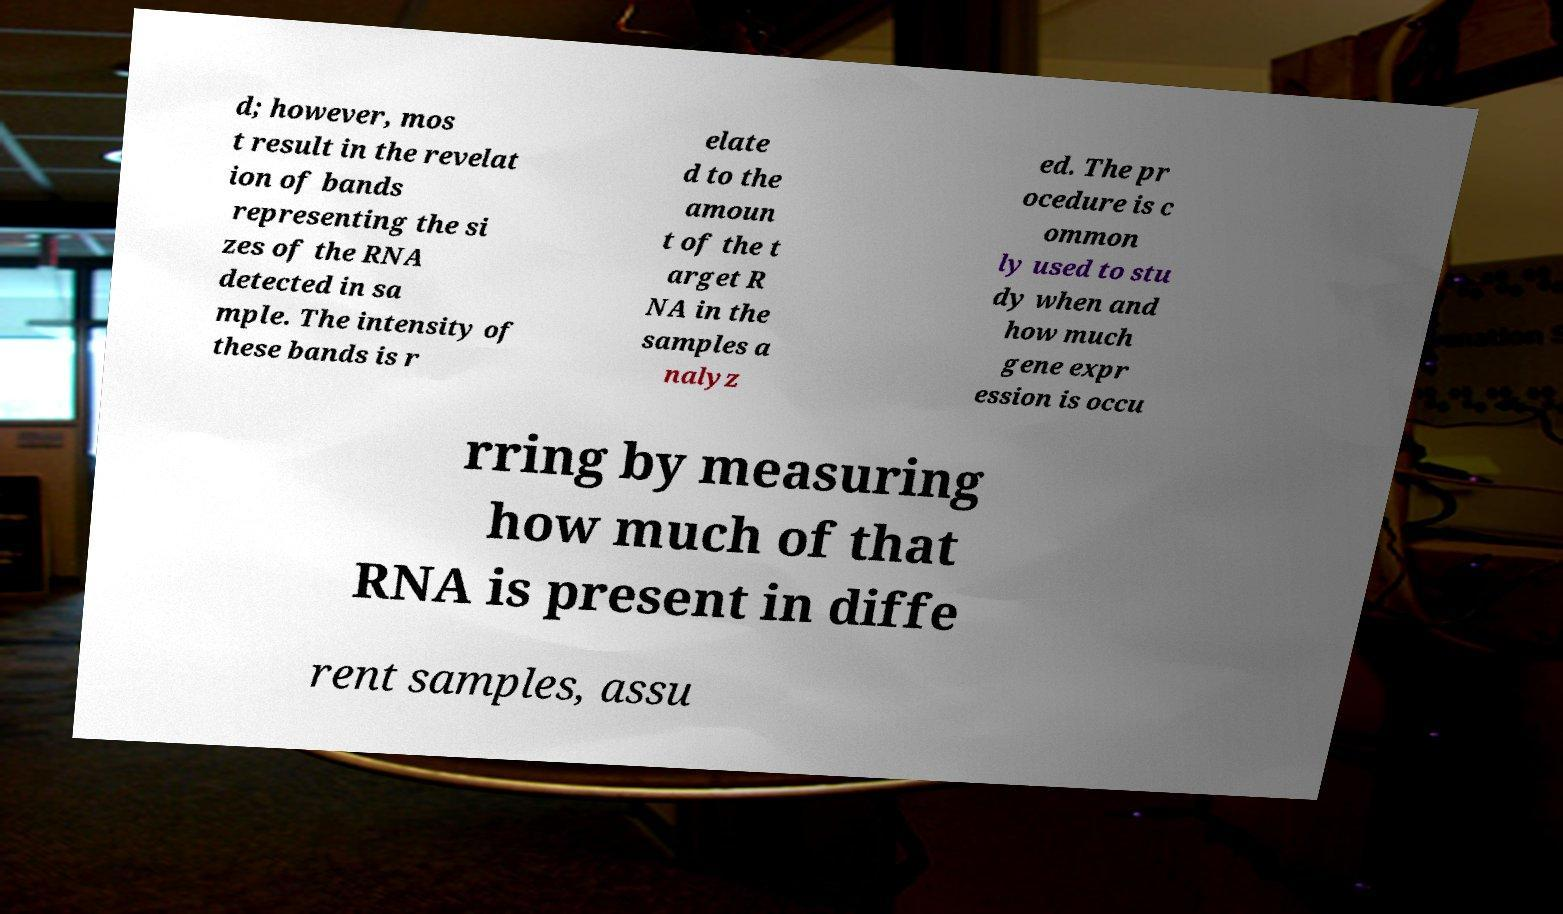For documentation purposes, I need the text within this image transcribed. Could you provide that? d; however, mos t result in the revelat ion of bands representing the si zes of the RNA detected in sa mple. The intensity of these bands is r elate d to the amoun t of the t arget R NA in the samples a nalyz ed. The pr ocedure is c ommon ly used to stu dy when and how much gene expr ession is occu rring by measuring how much of that RNA is present in diffe rent samples, assu 